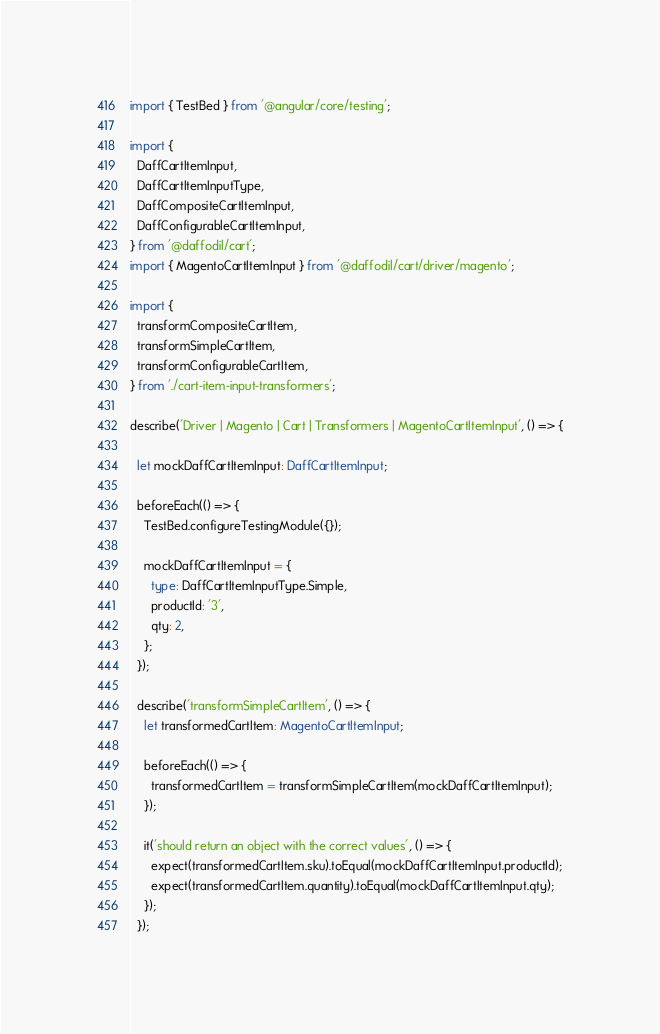<code> <loc_0><loc_0><loc_500><loc_500><_TypeScript_>import { TestBed } from '@angular/core/testing';

import {
  DaffCartItemInput,
  DaffCartItemInputType,
  DaffCompositeCartItemInput,
  DaffConfigurableCartItemInput,
} from '@daffodil/cart';
import { MagentoCartItemInput } from '@daffodil/cart/driver/magento';

import {
  transformCompositeCartItem,
  transformSimpleCartItem,
  transformConfigurableCartItem,
} from './cart-item-input-transformers';

describe('Driver | Magento | Cart | Transformers | MagentoCartItemInput', () => {

  let mockDaffCartItemInput: DaffCartItemInput;

  beforeEach(() => {
    TestBed.configureTestingModule({});

    mockDaffCartItemInput = {
      type: DaffCartItemInputType.Simple,
      productId: '3',
      qty: 2,
    };
  });

  describe('transformSimpleCartItem', () => {
    let transformedCartItem: MagentoCartItemInput;

    beforeEach(() => {
      transformedCartItem = transformSimpleCartItem(mockDaffCartItemInput);
    });

    it('should return an object with the correct values', () => {
      expect(transformedCartItem.sku).toEqual(mockDaffCartItemInput.productId);
      expect(transformedCartItem.quantity).toEqual(mockDaffCartItemInput.qty);
    });
  });
</code> 